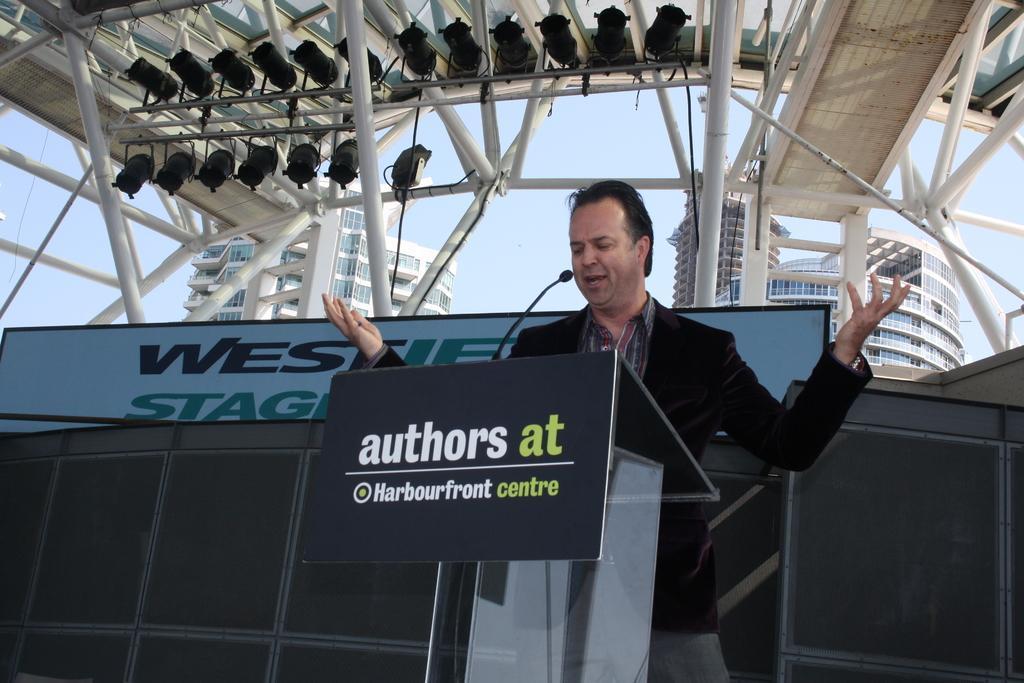Describe this image in one or two sentences. There is a man standing and talking,in front of this man we can see microphone on the podium. In the background we can see rods,hoarding,buildings and sky. 